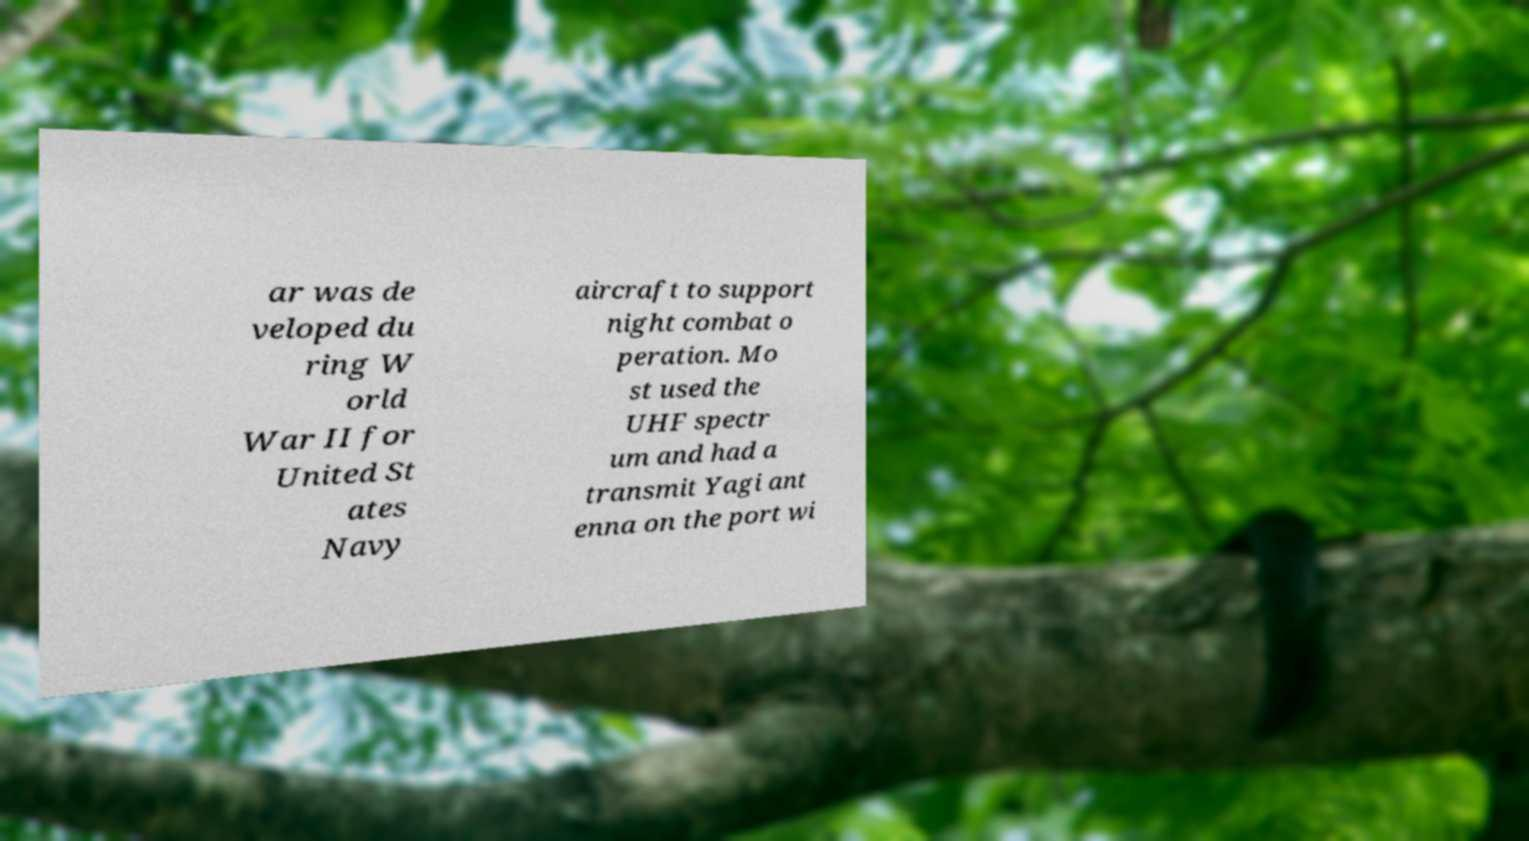I need the written content from this picture converted into text. Can you do that? ar was de veloped du ring W orld War II for United St ates Navy aircraft to support night combat o peration. Mo st used the UHF spectr um and had a transmit Yagi ant enna on the port wi 